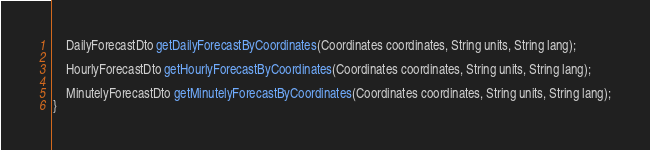<code> <loc_0><loc_0><loc_500><loc_500><_Java_>    DailyForecastDto getDailyForecastByCoordinates(Coordinates coordinates, String units, String lang);

    HourlyForecastDto getHourlyForecastByCoordinates(Coordinates coordinates, String units, String lang);

    MinutelyForecastDto getMinutelyForecastByCoordinates(Coordinates coordinates, String units, String lang);
}
</code> 